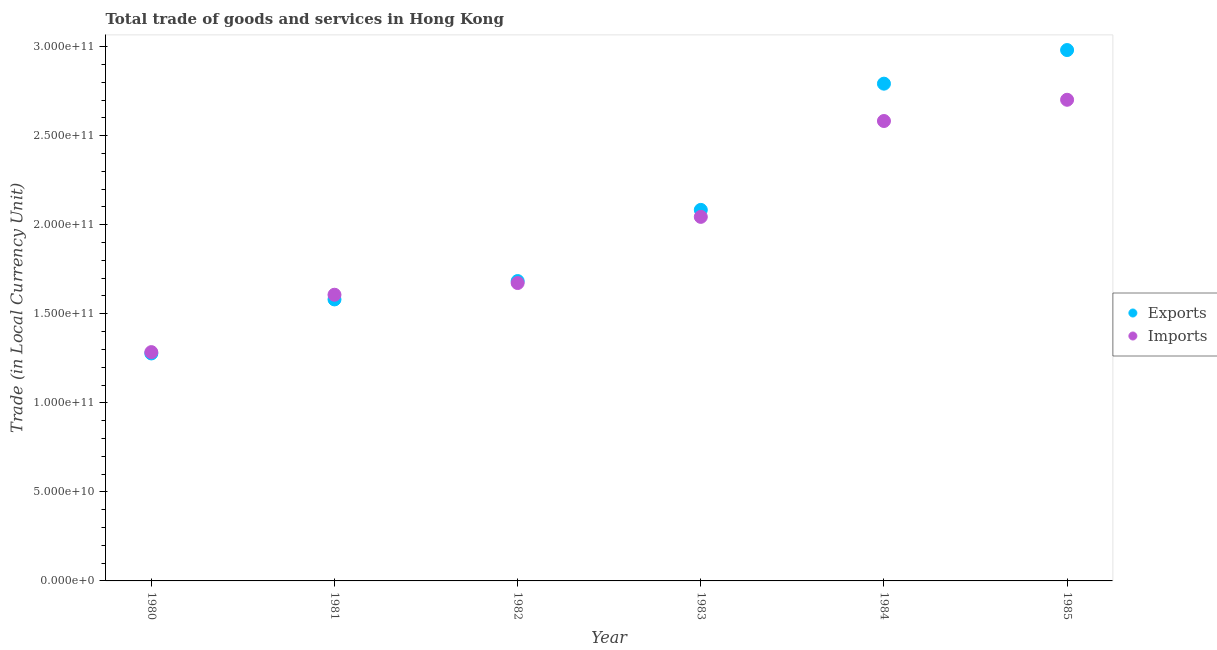Is the number of dotlines equal to the number of legend labels?
Make the answer very short. Yes. What is the imports of goods and services in 1984?
Provide a short and direct response. 2.58e+11. Across all years, what is the maximum export of goods and services?
Give a very brief answer. 2.98e+11. Across all years, what is the minimum export of goods and services?
Your answer should be compact. 1.28e+11. In which year was the export of goods and services maximum?
Your answer should be very brief. 1985. What is the total export of goods and services in the graph?
Your response must be concise. 1.24e+12. What is the difference between the export of goods and services in 1980 and that in 1985?
Keep it short and to the point. -1.70e+11. What is the difference between the imports of goods and services in 1985 and the export of goods and services in 1983?
Your answer should be compact. 6.18e+1. What is the average imports of goods and services per year?
Provide a succinct answer. 1.98e+11. In the year 1984, what is the difference between the imports of goods and services and export of goods and services?
Ensure brevity in your answer.  -2.10e+1. In how many years, is the imports of goods and services greater than 80000000000 LCU?
Keep it short and to the point. 6. What is the ratio of the export of goods and services in 1981 to that in 1982?
Provide a succinct answer. 0.94. What is the difference between the highest and the second highest imports of goods and services?
Your answer should be very brief. 1.19e+1. What is the difference between the highest and the lowest export of goods and services?
Offer a terse response. 1.70e+11. In how many years, is the export of goods and services greater than the average export of goods and services taken over all years?
Offer a terse response. 3. Does the imports of goods and services monotonically increase over the years?
Provide a succinct answer. Yes. What is the difference between two consecutive major ticks on the Y-axis?
Make the answer very short. 5.00e+1. Are the values on the major ticks of Y-axis written in scientific E-notation?
Your response must be concise. Yes. How many legend labels are there?
Give a very brief answer. 2. What is the title of the graph?
Offer a terse response. Total trade of goods and services in Hong Kong. What is the label or title of the Y-axis?
Offer a terse response. Trade (in Local Currency Unit). What is the Trade (in Local Currency Unit) of Exports in 1980?
Offer a very short reply. 1.28e+11. What is the Trade (in Local Currency Unit) in Imports in 1980?
Give a very brief answer. 1.28e+11. What is the Trade (in Local Currency Unit) of Exports in 1981?
Your answer should be very brief. 1.58e+11. What is the Trade (in Local Currency Unit) of Imports in 1981?
Your response must be concise. 1.61e+11. What is the Trade (in Local Currency Unit) of Exports in 1982?
Keep it short and to the point. 1.68e+11. What is the Trade (in Local Currency Unit) in Imports in 1982?
Offer a terse response. 1.67e+11. What is the Trade (in Local Currency Unit) of Exports in 1983?
Ensure brevity in your answer.  2.08e+11. What is the Trade (in Local Currency Unit) of Imports in 1983?
Ensure brevity in your answer.  2.04e+11. What is the Trade (in Local Currency Unit) of Exports in 1984?
Your answer should be very brief. 2.79e+11. What is the Trade (in Local Currency Unit) of Imports in 1984?
Give a very brief answer. 2.58e+11. What is the Trade (in Local Currency Unit) in Exports in 1985?
Your response must be concise. 2.98e+11. What is the Trade (in Local Currency Unit) in Imports in 1985?
Offer a very short reply. 2.70e+11. Across all years, what is the maximum Trade (in Local Currency Unit) in Exports?
Give a very brief answer. 2.98e+11. Across all years, what is the maximum Trade (in Local Currency Unit) of Imports?
Ensure brevity in your answer.  2.70e+11. Across all years, what is the minimum Trade (in Local Currency Unit) in Exports?
Your response must be concise. 1.28e+11. Across all years, what is the minimum Trade (in Local Currency Unit) in Imports?
Make the answer very short. 1.28e+11. What is the total Trade (in Local Currency Unit) of Exports in the graph?
Ensure brevity in your answer.  1.24e+12. What is the total Trade (in Local Currency Unit) of Imports in the graph?
Your answer should be very brief. 1.19e+12. What is the difference between the Trade (in Local Currency Unit) in Exports in 1980 and that in 1981?
Offer a terse response. -3.03e+1. What is the difference between the Trade (in Local Currency Unit) of Imports in 1980 and that in 1981?
Make the answer very short. -3.22e+1. What is the difference between the Trade (in Local Currency Unit) of Exports in 1980 and that in 1982?
Your answer should be compact. -4.06e+1. What is the difference between the Trade (in Local Currency Unit) in Imports in 1980 and that in 1982?
Offer a very short reply. -3.88e+1. What is the difference between the Trade (in Local Currency Unit) in Exports in 1980 and that in 1983?
Provide a succinct answer. -8.06e+1. What is the difference between the Trade (in Local Currency Unit) in Imports in 1980 and that in 1983?
Your answer should be very brief. -7.59e+1. What is the difference between the Trade (in Local Currency Unit) in Exports in 1980 and that in 1984?
Provide a succinct answer. -1.51e+11. What is the difference between the Trade (in Local Currency Unit) of Imports in 1980 and that in 1984?
Keep it short and to the point. -1.30e+11. What is the difference between the Trade (in Local Currency Unit) of Exports in 1980 and that in 1985?
Your response must be concise. -1.70e+11. What is the difference between the Trade (in Local Currency Unit) in Imports in 1980 and that in 1985?
Provide a succinct answer. -1.42e+11. What is the difference between the Trade (in Local Currency Unit) in Exports in 1981 and that in 1982?
Keep it short and to the point. -1.03e+1. What is the difference between the Trade (in Local Currency Unit) in Imports in 1981 and that in 1982?
Your answer should be very brief. -6.58e+09. What is the difference between the Trade (in Local Currency Unit) of Exports in 1981 and that in 1983?
Make the answer very short. -5.03e+1. What is the difference between the Trade (in Local Currency Unit) in Imports in 1981 and that in 1983?
Your response must be concise. -4.37e+1. What is the difference between the Trade (in Local Currency Unit) of Exports in 1981 and that in 1984?
Your answer should be very brief. -1.21e+11. What is the difference between the Trade (in Local Currency Unit) in Imports in 1981 and that in 1984?
Offer a terse response. -9.75e+1. What is the difference between the Trade (in Local Currency Unit) of Exports in 1981 and that in 1985?
Keep it short and to the point. -1.40e+11. What is the difference between the Trade (in Local Currency Unit) in Imports in 1981 and that in 1985?
Offer a terse response. -1.09e+11. What is the difference between the Trade (in Local Currency Unit) in Exports in 1982 and that in 1983?
Your answer should be compact. -4.00e+1. What is the difference between the Trade (in Local Currency Unit) in Imports in 1982 and that in 1983?
Your answer should be compact. -3.71e+1. What is the difference between the Trade (in Local Currency Unit) in Exports in 1982 and that in 1984?
Ensure brevity in your answer.  -1.11e+11. What is the difference between the Trade (in Local Currency Unit) in Imports in 1982 and that in 1984?
Your response must be concise. -9.10e+1. What is the difference between the Trade (in Local Currency Unit) in Exports in 1982 and that in 1985?
Provide a succinct answer. -1.30e+11. What is the difference between the Trade (in Local Currency Unit) in Imports in 1982 and that in 1985?
Your answer should be very brief. -1.03e+11. What is the difference between the Trade (in Local Currency Unit) of Exports in 1983 and that in 1984?
Give a very brief answer. -7.09e+1. What is the difference between the Trade (in Local Currency Unit) in Imports in 1983 and that in 1984?
Your answer should be very brief. -5.38e+1. What is the difference between the Trade (in Local Currency Unit) in Exports in 1983 and that in 1985?
Your response must be concise. -8.97e+1. What is the difference between the Trade (in Local Currency Unit) in Imports in 1983 and that in 1985?
Make the answer very short. -6.57e+1. What is the difference between the Trade (in Local Currency Unit) in Exports in 1984 and that in 1985?
Your response must be concise. -1.89e+1. What is the difference between the Trade (in Local Currency Unit) of Imports in 1984 and that in 1985?
Offer a very short reply. -1.19e+1. What is the difference between the Trade (in Local Currency Unit) of Exports in 1980 and the Trade (in Local Currency Unit) of Imports in 1981?
Provide a short and direct response. -3.30e+1. What is the difference between the Trade (in Local Currency Unit) of Exports in 1980 and the Trade (in Local Currency Unit) of Imports in 1982?
Keep it short and to the point. -3.95e+1. What is the difference between the Trade (in Local Currency Unit) of Exports in 1980 and the Trade (in Local Currency Unit) of Imports in 1983?
Make the answer very short. -7.67e+1. What is the difference between the Trade (in Local Currency Unit) of Exports in 1980 and the Trade (in Local Currency Unit) of Imports in 1984?
Provide a succinct answer. -1.31e+11. What is the difference between the Trade (in Local Currency Unit) in Exports in 1980 and the Trade (in Local Currency Unit) in Imports in 1985?
Your response must be concise. -1.42e+11. What is the difference between the Trade (in Local Currency Unit) of Exports in 1981 and the Trade (in Local Currency Unit) of Imports in 1982?
Offer a terse response. -9.21e+09. What is the difference between the Trade (in Local Currency Unit) in Exports in 1981 and the Trade (in Local Currency Unit) in Imports in 1983?
Your response must be concise. -4.64e+1. What is the difference between the Trade (in Local Currency Unit) of Exports in 1981 and the Trade (in Local Currency Unit) of Imports in 1984?
Offer a terse response. -1.00e+11. What is the difference between the Trade (in Local Currency Unit) of Exports in 1981 and the Trade (in Local Currency Unit) of Imports in 1985?
Your answer should be compact. -1.12e+11. What is the difference between the Trade (in Local Currency Unit) of Exports in 1982 and the Trade (in Local Currency Unit) of Imports in 1983?
Make the answer very short. -3.60e+1. What is the difference between the Trade (in Local Currency Unit) in Exports in 1982 and the Trade (in Local Currency Unit) in Imports in 1984?
Offer a terse response. -8.99e+1. What is the difference between the Trade (in Local Currency Unit) of Exports in 1982 and the Trade (in Local Currency Unit) of Imports in 1985?
Give a very brief answer. -1.02e+11. What is the difference between the Trade (in Local Currency Unit) of Exports in 1983 and the Trade (in Local Currency Unit) of Imports in 1984?
Your answer should be very brief. -4.99e+1. What is the difference between the Trade (in Local Currency Unit) in Exports in 1983 and the Trade (in Local Currency Unit) in Imports in 1985?
Your answer should be very brief. -6.18e+1. What is the difference between the Trade (in Local Currency Unit) in Exports in 1984 and the Trade (in Local Currency Unit) in Imports in 1985?
Provide a succinct answer. 9.04e+09. What is the average Trade (in Local Currency Unit) of Exports per year?
Your answer should be compact. 2.07e+11. What is the average Trade (in Local Currency Unit) of Imports per year?
Your answer should be compact. 1.98e+11. In the year 1980, what is the difference between the Trade (in Local Currency Unit) in Exports and Trade (in Local Currency Unit) in Imports?
Ensure brevity in your answer.  -7.42e+08. In the year 1981, what is the difference between the Trade (in Local Currency Unit) of Exports and Trade (in Local Currency Unit) of Imports?
Keep it short and to the point. -2.64e+09. In the year 1982, what is the difference between the Trade (in Local Currency Unit) of Exports and Trade (in Local Currency Unit) of Imports?
Make the answer very short. 1.11e+09. In the year 1983, what is the difference between the Trade (in Local Currency Unit) of Exports and Trade (in Local Currency Unit) of Imports?
Make the answer very short. 3.92e+09. In the year 1984, what is the difference between the Trade (in Local Currency Unit) of Exports and Trade (in Local Currency Unit) of Imports?
Ensure brevity in your answer.  2.10e+1. In the year 1985, what is the difference between the Trade (in Local Currency Unit) of Exports and Trade (in Local Currency Unit) of Imports?
Make the answer very short. 2.79e+1. What is the ratio of the Trade (in Local Currency Unit) of Exports in 1980 to that in 1981?
Your response must be concise. 0.81. What is the ratio of the Trade (in Local Currency Unit) of Imports in 1980 to that in 1981?
Your answer should be compact. 0.8. What is the ratio of the Trade (in Local Currency Unit) of Exports in 1980 to that in 1982?
Your answer should be very brief. 0.76. What is the ratio of the Trade (in Local Currency Unit) in Imports in 1980 to that in 1982?
Give a very brief answer. 0.77. What is the ratio of the Trade (in Local Currency Unit) of Exports in 1980 to that in 1983?
Provide a short and direct response. 0.61. What is the ratio of the Trade (in Local Currency Unit) of Imports in 1980 to that in 1983?
Give a very brief answer. 0.63. What is the ratio of the Trade (in Local Currency Unit) of Exports in 1980 to that in 1984?
Your answer should be very brief. 0.46. What is the ratio of the Trade (in Local Currency Unit) of Imports in 1980 to that in 1984?
Offer a terse response. 0.5. What is the ratio of the Trade (in Local Currency Unit) of Exports in 1980 to that in 1985?
Your answer should be very brief. 0.43. What is the ratio of the Trade (in Local Currency Unit) of Imports in 1980 to that in 1985?
Offer a terse response. 0.48. What is the ratio of the Trade (in Local Currency Unit) of Exports in 1981 to that in 1982?
Provide a succinct answer. 0.94. What is the ratio of the Trade (in Local Currency Unit) in Imports in 1981 to that in 1982?
Ensure brevity in your answer.  0.96. What is the ratio of the Trade (in Local Currency Unit) of Exports in 1981 to that in 1983?
Offer a very short reply. 0.76. What is the ratio of the Trade (in Local Currency Unit) of Imports in 1981 to that in 1983?
Offer a terse response. 0.79. What is the ratio of the Trade (in Local Currency Unit) of Exports in 1981 to that in 1984?
Offer a terse response. 0.57. What is the ratio of the Trade (in Local Currency Unit) in Imports in 1981 to that in 1984?
Ensure brevity in your answer.  0.62. What is the ratio of the Trade (in Local Currency Unit) in Exports in 1981 to that in 1985?
Provide a succinct answer. 0.53. What is the ratio of the Trade (in Local Currency Unit) of Imports in 1981 to that in 1985?
Offer a very short reply. 0.59. What is the ratio of the Trade (in Local Currency Unit) of Exports in 1982 to that in 1983?
Offer a very short reply. 0.81. What is the ratio of the Trade (in Local Currency Unit) of Imports in 1982 to that in 1983?
Provide a short and direct response. 0.82. What is the ratio of the Trade (in Local Currency Unit) of Exports in 1982 to that in 1984?
Make the answer very short. 0.6. What is the ratio of the Trade (in Local Currency Unit) of Imports in 1982 to that in 1984?
Provide a short and direct response. 0.65. What is the ratio of the Trade (in Local Currency Unit) of Exports in 1982 to that in 1985?
Keep it short and to the point. 0.56. What is the ratio of the Trade (in Local Currency Unit) in Imports in 1982 to that in 1985?
Offer a very short reply. 0.62. What is the ratio of the Trade (in Local Currency Unit) in Exports in 1983 to that in 1984?
Offer a terse response. 0.75. What is the ratio of the Trade (in Local Currency Unit) of Imports in 1983 to that in 1984?
Provide a succinct answer. 0.79. What is the ratio of the Trade (in Local Currency Unit) of Exports in 1983 to that in 1985?
Keep it short and to the point. 0.7. What is the ratio of the Trade (in Local Currency Unit) in Imports in 1983 to that in 1985?
Make the answer very short. 0.76. What is the ratio of the Trade (in Local Currency Unit) of Exports in 1984 to that in 1985?
Provide a succinct answer. 0.94. What is the ratio of the Trade (in Local Currency Unit) in Imports in 1984 to that in 1985?
Your answer should be very brief. 0.96. What is the difference between the highest and the second highest Trade (in Local Currency Unit) of Exports?
Offer a very short reply. 1.89e+1. What is the difference between the highest and the second highest Trade (in Local Currency Unit) in Imports?
Make the answer very short. 1.19e+1. What is the difference between the highest and the lowest Trade (in Local Currency Unit) in Exports?
Your answer should be compact. 1.70e+11. What is the difference between the highest and the lowest Trade (in Local Currency Unit) in Imports?
Make the answer very short. 1.42e+11. 